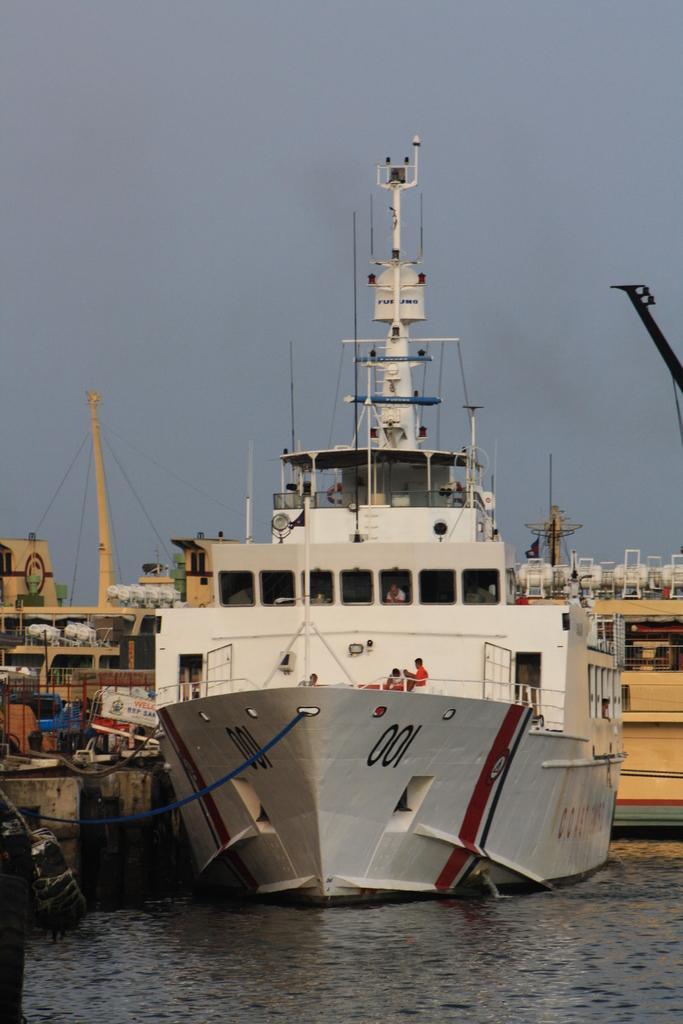In one or two sentences, can you explain what this image depicts? In this picture we can see ships on the water, here we can see people and some objects and we can see sky in the background. 